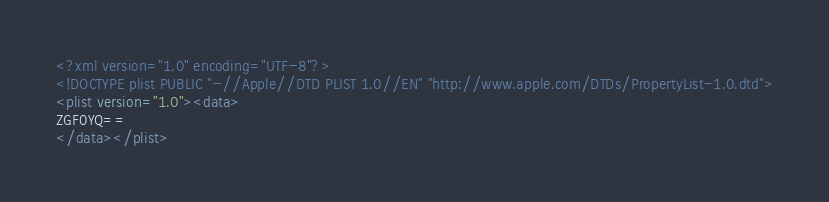Convert code to text. <code><loc_0><loc_0><loc_500><loc_500><_XML_><?xml version="1.0" encoding="UTF-8"?>
<!DOCTYPE plist PUBLIC "-//Apple//DTD PLIST 1.0//EN" "http://www.apple.com/DTDs/PropertyList-1.0.dtd">
<plist version="1.0"><data>
ZGF0YQ==
</data></plist>
</code> 